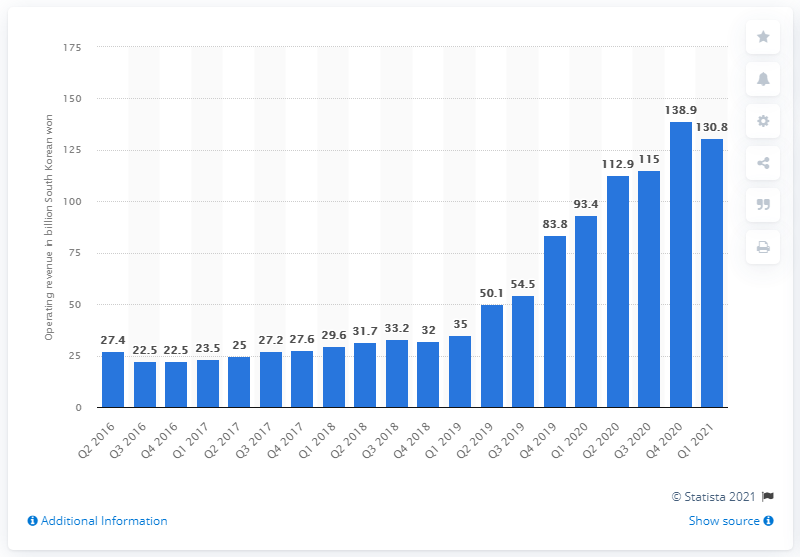Identify some key points in this picture. During the first quarter of 2021, Naver's revenue from its contents service segment was 130.8... 